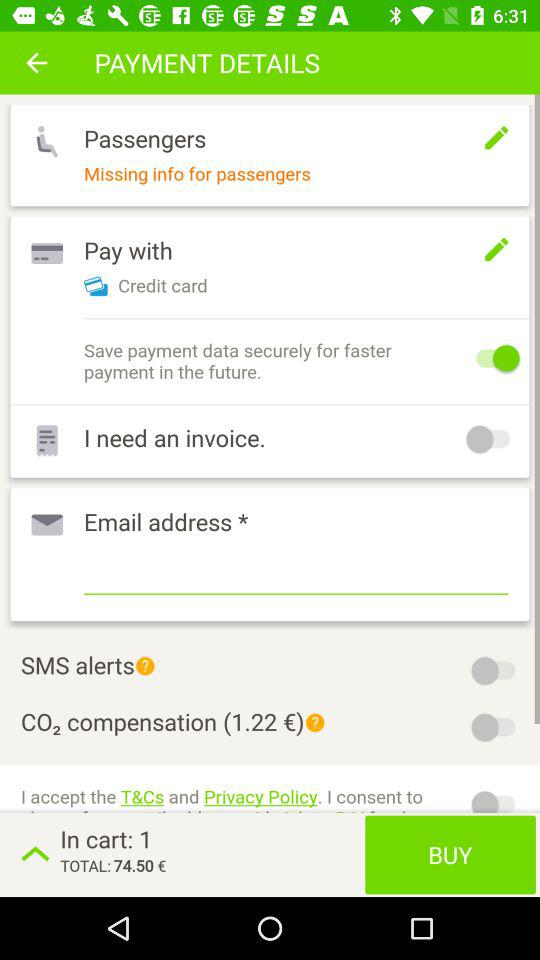What is the option to pay? The option to pay is "Credit card". 